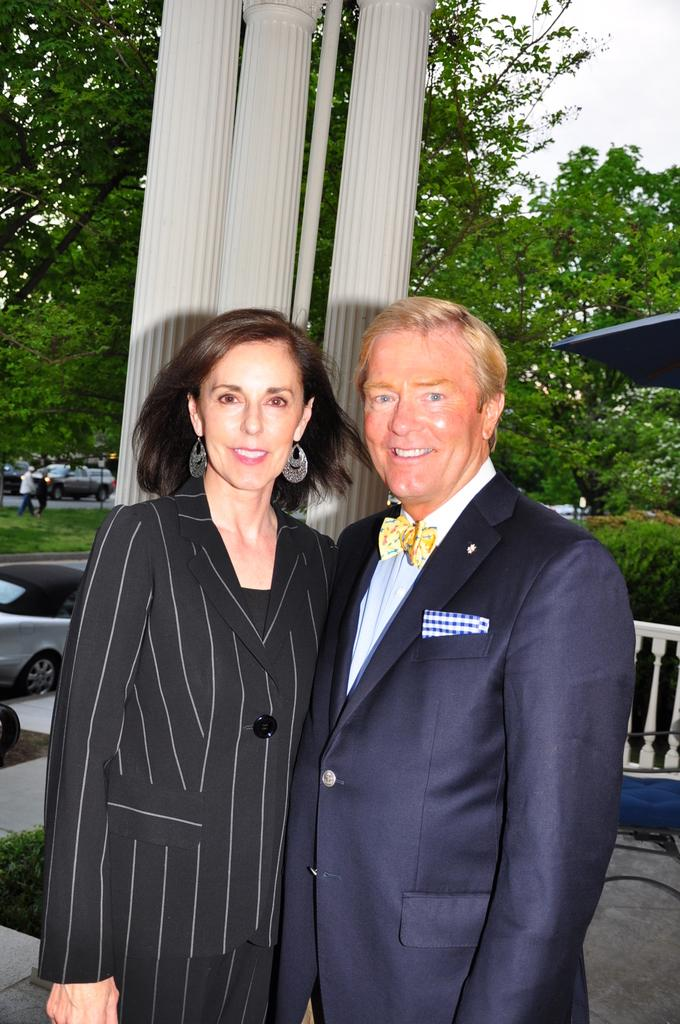How many people are present in the image? There are two people, a man and a woman, present in the image. What are the man and woman doing in the image? Both the man and woman are posing for a camera. What is the facial expression of the man and woman? The man and woman are smiling. What can be seen in the background of the image? There are pillars, trees, vehicles, grass, and the sky visible in the background of the image. What type of zinc can be seen in the image? There is no zinc present in the image. How many eyes can be seen in the image? The image only shows a man and a woman, so there are two sets of eyes visible. 